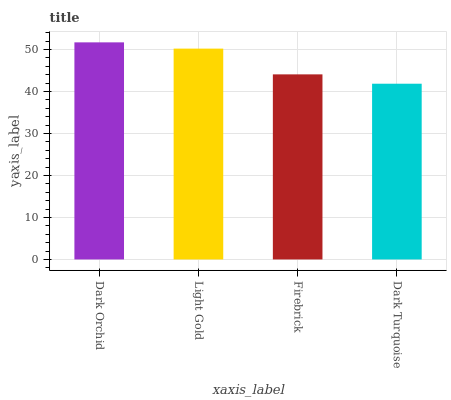Is Dark Turquoise the minimum?
Answer yes or no. Yes. Is Dark Orchid the maximum?
Answer yes or no. Yes. Is Light Gold the minimum?
Answer yes or no. No. Is Light Gold the maximum?
Answer yes or no. No. Is Dark Orchid greater than Light Gold?
Answer yes or no. Yes. Is Light Gold less than Dark Orchid?
Answer yes or no. Yes. Is Light Gold greater than Dark Orchid?
Answer yes or no. No. Is Dark Orchid less than Light Gold?
Answer yes or no. No. Is Light Gold the high median?
Answer yes or no. Yes. Is Firebrick the low median?
Answer yes or no. Yes. Is Dark Orchid the high median?
Answer yes or no. No. Is Dark Orchid the low median?
Answer yes or no. No. 